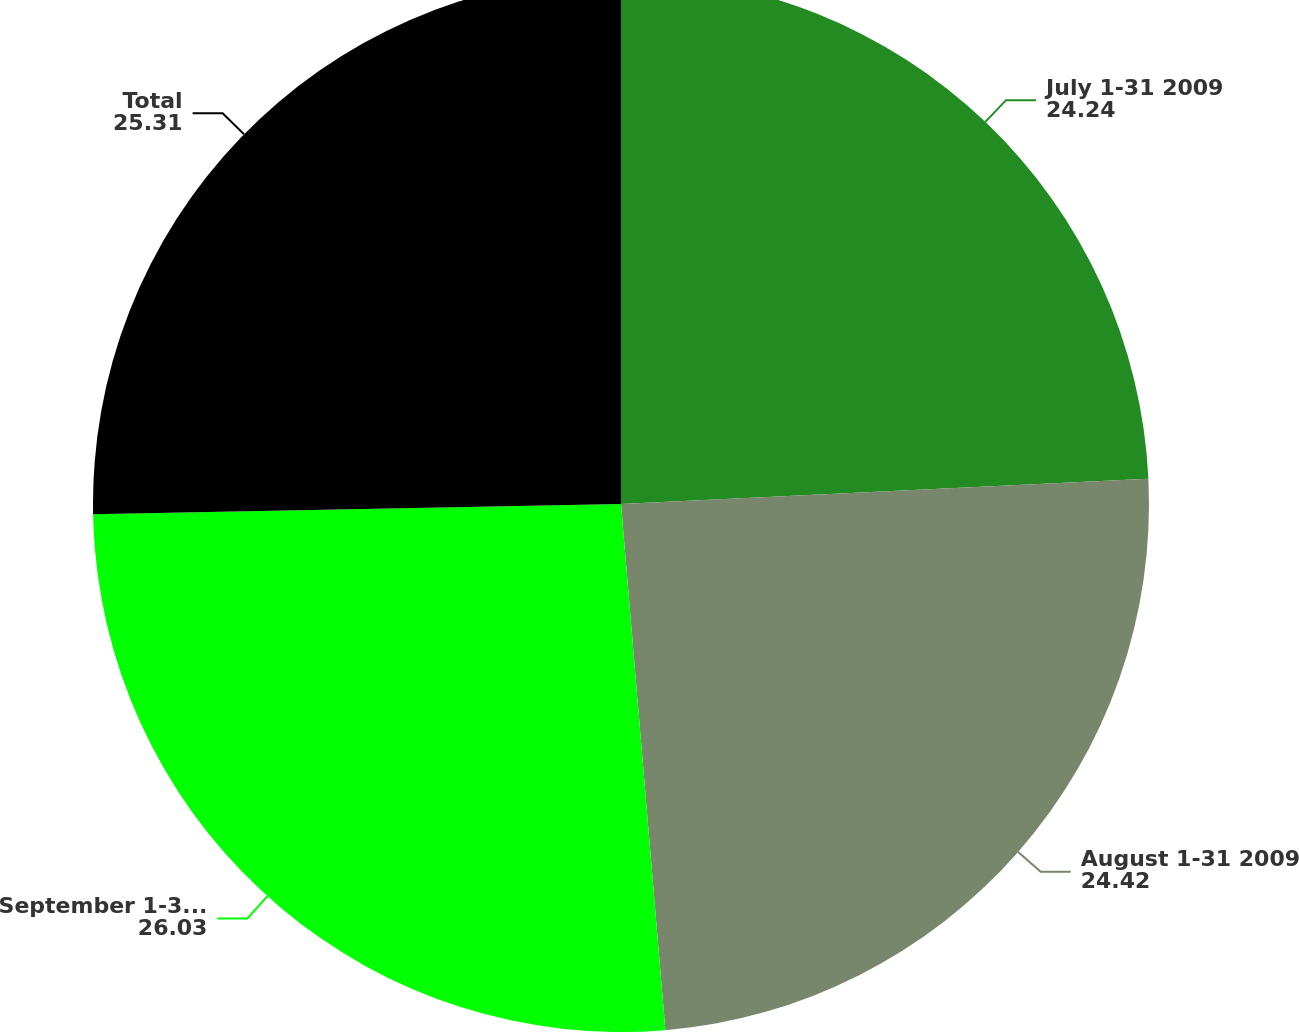<chart> <loc_0><loc_0><loc_500><loc_500><pie_chart><fcel>July 1-31 2009<fcel>August 1-31 2009<fcel>September 1-30 2009<fcel>Total<nl><fcel>24.24%<fcel>24.42%<fcel>26.03%<fcel>25.31%<nl></chart> 